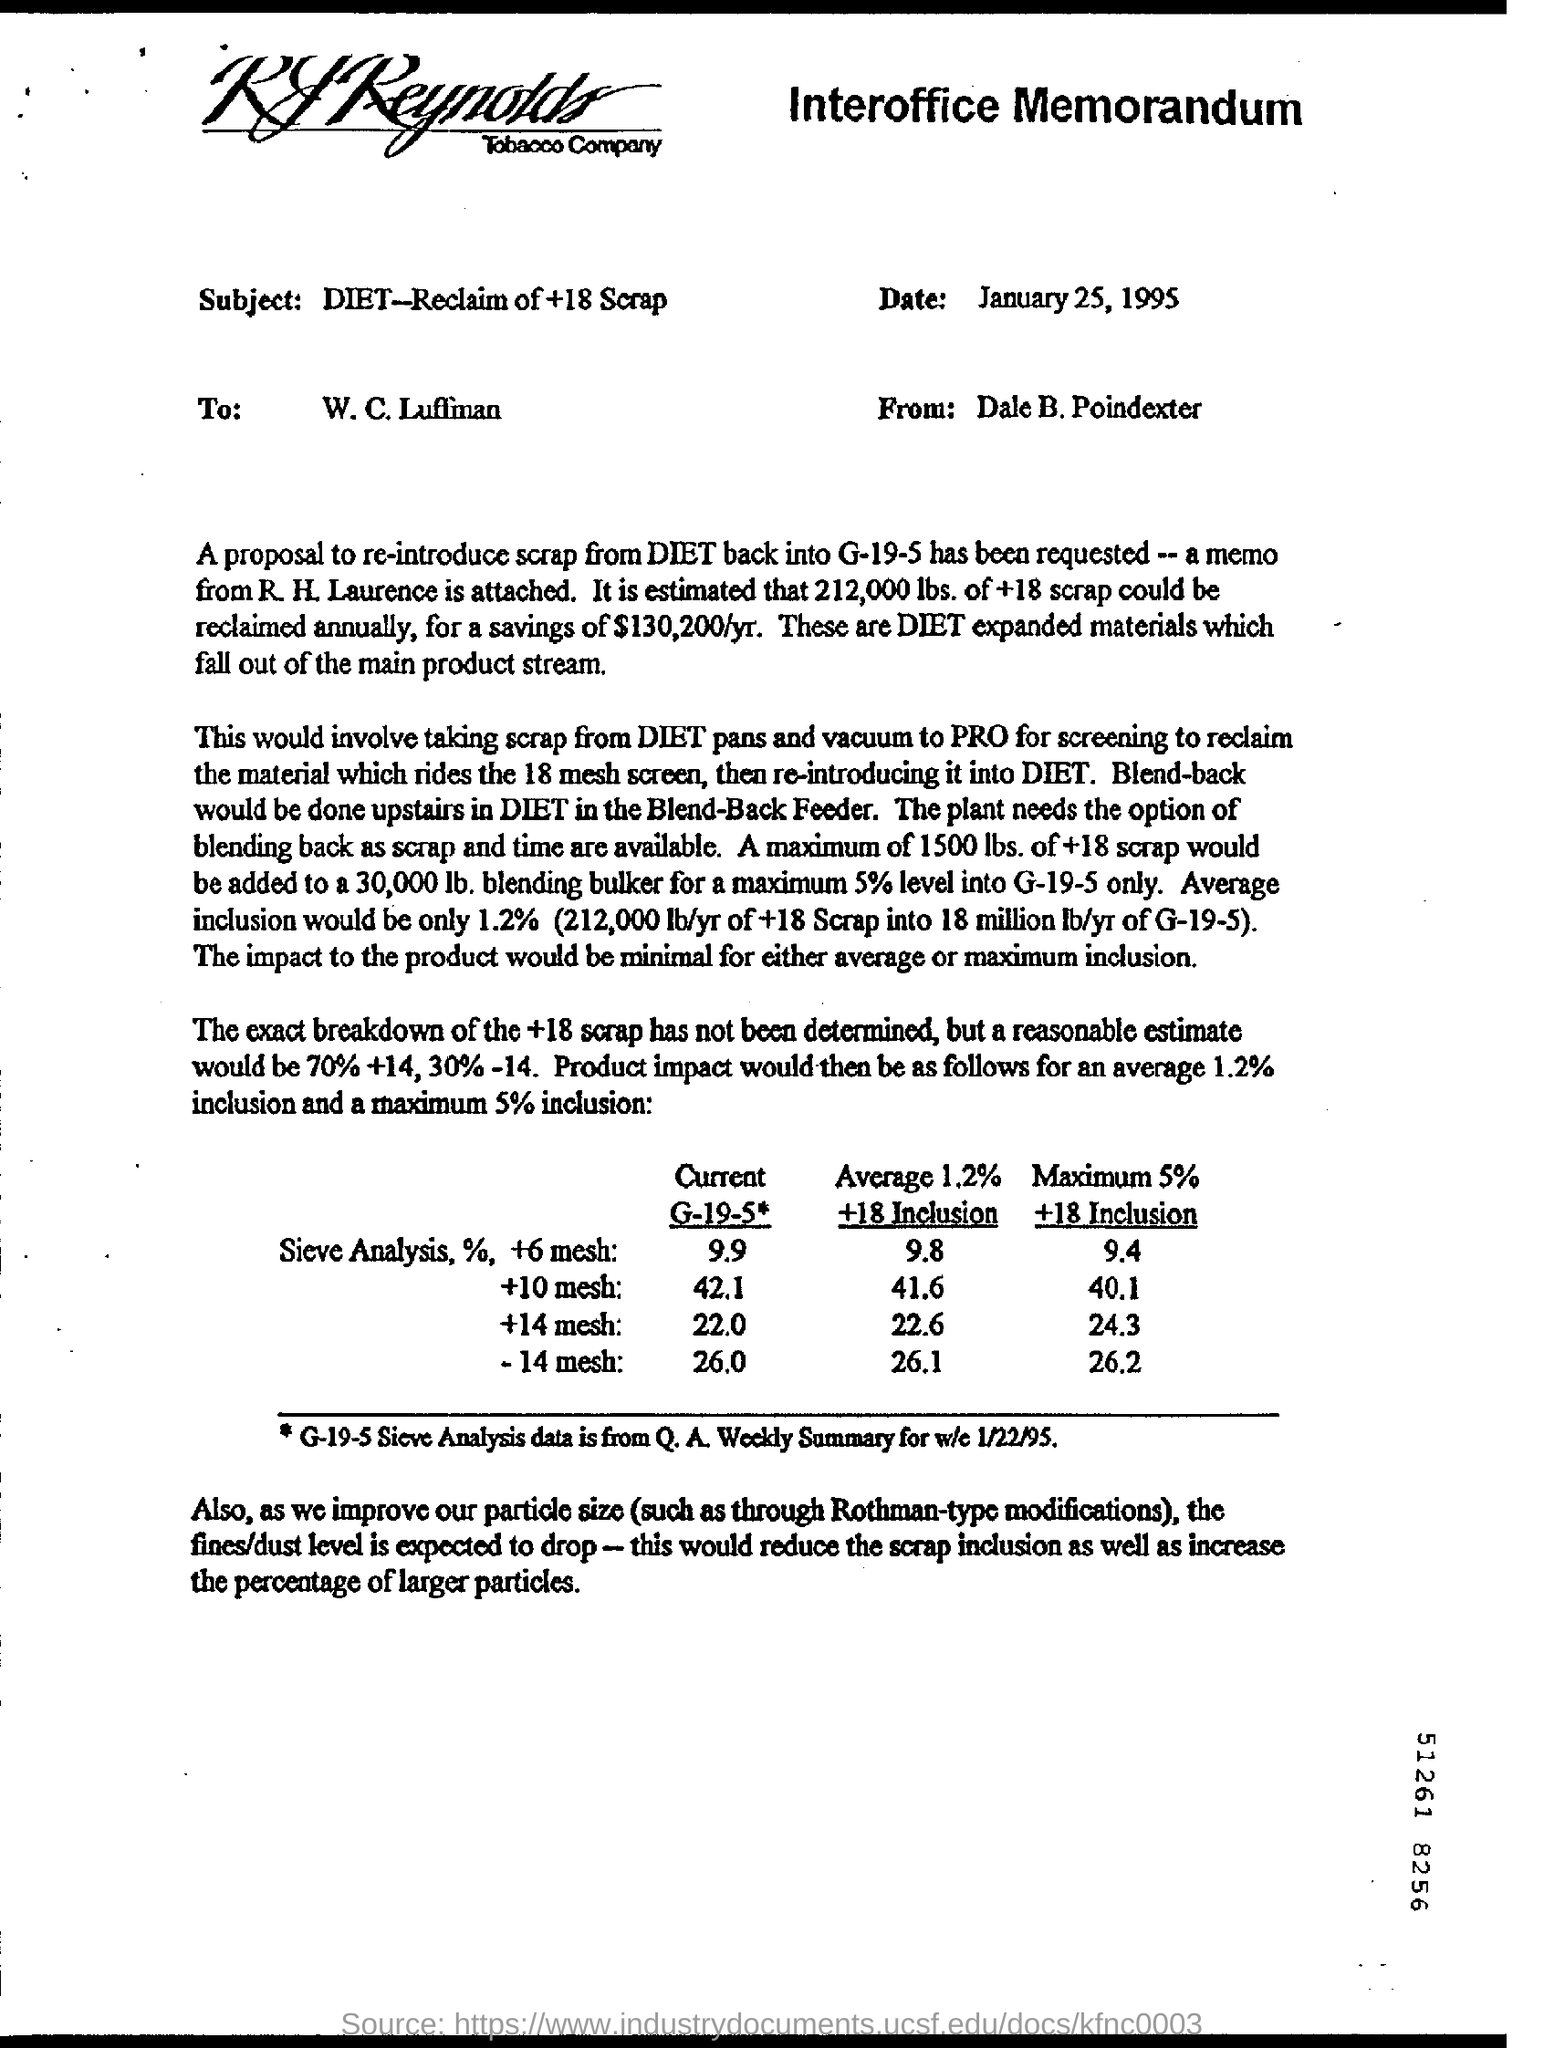Give some essential details in this illustration. The subject of the interoffice memorandum is "DIET - Reclamation of +18 Scrap. The proposal is to reintroduce scrap from DIET back into g-19-5. The G-19-5 Sieve Analysis data were taken from a specific source or location. The Q.A. Weekly Summary for the week ending on January 22, 1995, provides a summary of the activities and events that occurred during that week. 